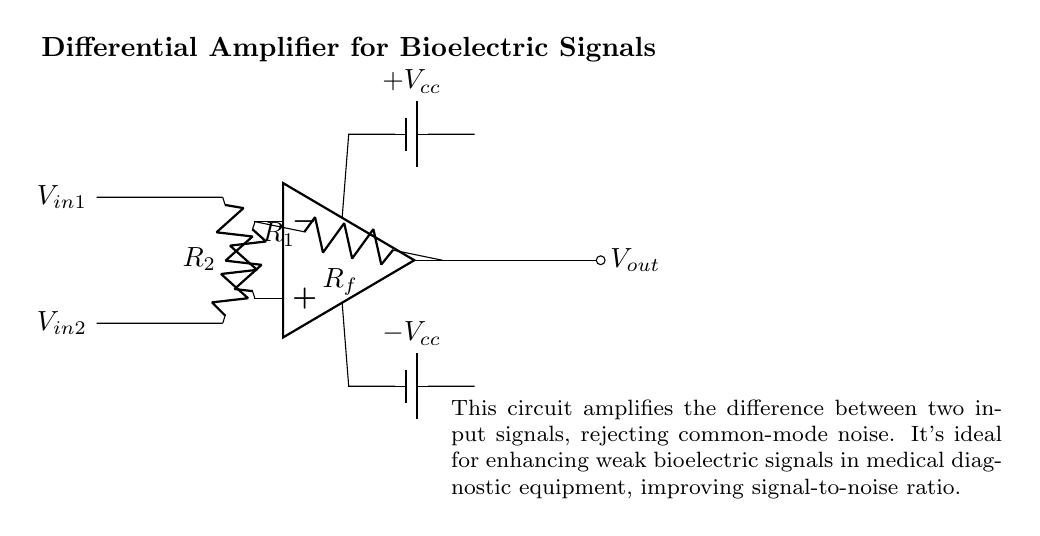What type of amplifier is shown in the circuit? The circuit is labeled as a "Differential Amplifier", which specifically amplifies the difference between two input signals.
Answer: Differential Amplifier What are the values of the resistors used in the circuit? The resistors are labeled as R1, R2, and Rf, but their specific numerical values are not provided in the diagram.
Answer: R1, R2, Rf What do the input signals represent in the context of this circuit? The input signals, labeled V_in1 and V_in2, represent the bioelectric signals that are being compared and amplified by the circuit.
Answer: Bioelectric signals How does the circuit enhance weak bioelectric signals? The differential amplifier design rejects common-mode noise, allowing it to focus on the difference between two bioelectric signals, which enhances the overall signal-to-noise ratio.
Answer: By rejecting common-mode noise What is the function of the feedback resistor in this circuit? The feedback resistor Rf connects the output back to the inverting input of the op-amp, which helps set the gain of the amplifier and stabilize the circuit's performance.
Answer: Sets gain and stabilizes performance What does the power supply configuration indicate about the operational amplifier? The power supply configuration provides dual voltages (+V_cc and -V_cc), indicating the operational amplifier can amplify both positive and negative signals, enabling it to handle a wider range of input voltages.
Answer: Dual supply for positive and negative signals 